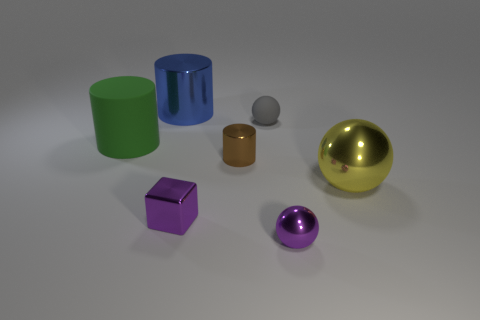Add 1 small purple metallic objects. How many objects exist? 8 Subtract all small metallic balls. How many balls are left? 2 Subtract all cylinders. How many objects are left? 4 Subtract all big blue metal things. Subtract all yellow shiny objects. How many objects are left? 5 Add 1 gray objects. How many gray objects are left? 2 Add 6 large blue things. How many large blue things exist? 7 Subtract 1 gray spheres. How many objects are left? 6 Subtract 2 cylinders. How many cylinders are left? 1 Subtract all cyan balls. Subtract all gray cylinders. How many balls are left? 3 